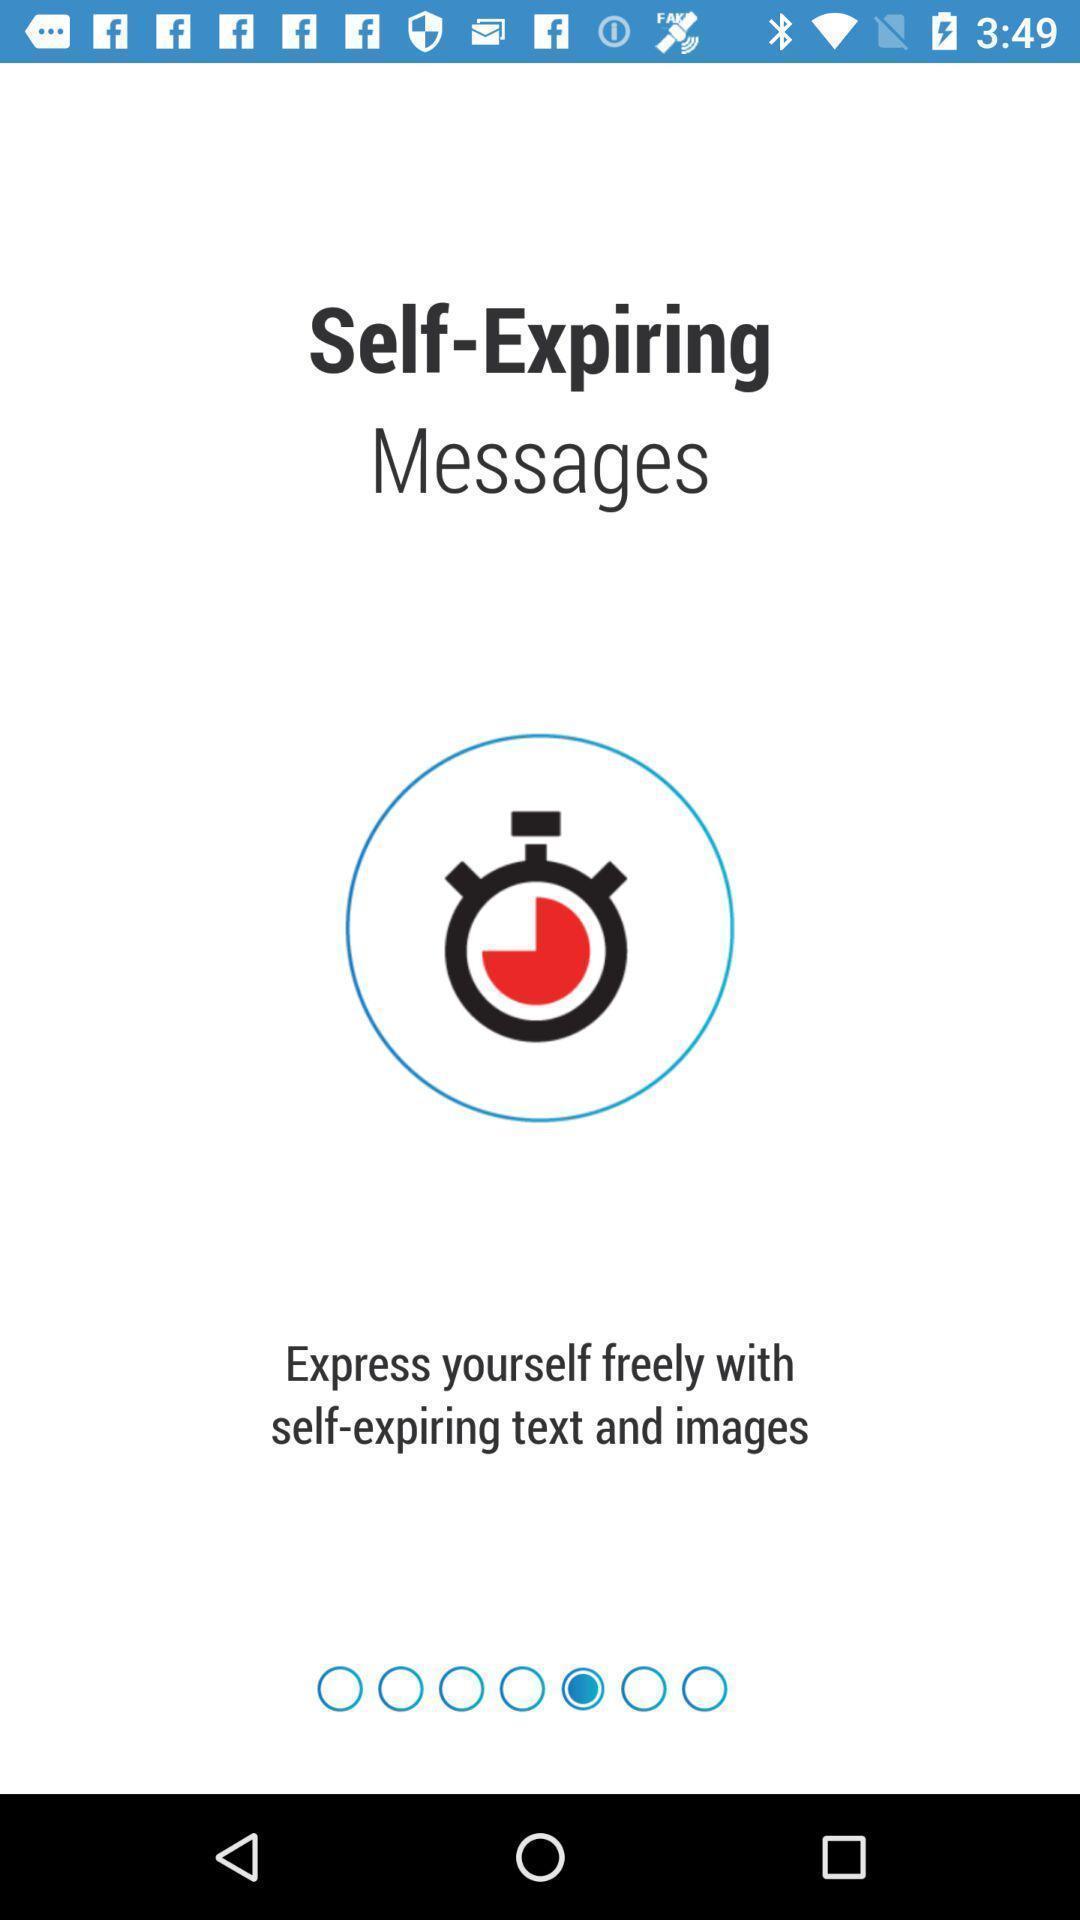What details can you identify in this image? Welcome page. 